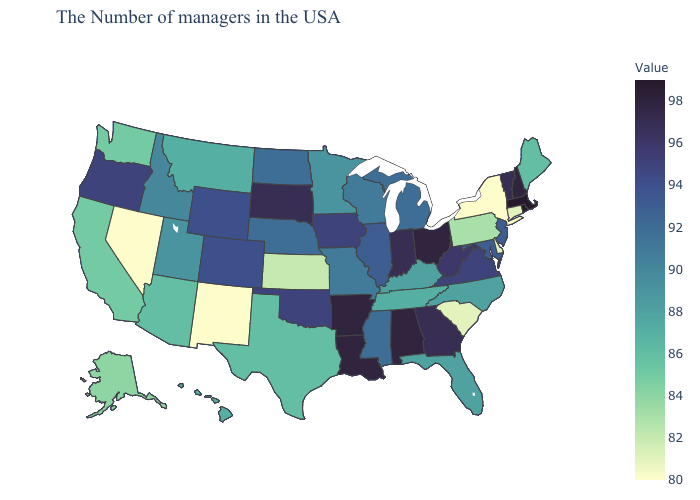Among the states that border South Carolina , does North Carolina have the lowest value?
Write a very short answer. Yes. Does Delaware have a higher value than Arkansas?
Concise answer only. No. Among the states that border Colorado , does New Mexico have the lowest value?
Give a very brief answer. Yes. Does New York have the lowest value in the Northeast?
Write a very short answer. Yes. 